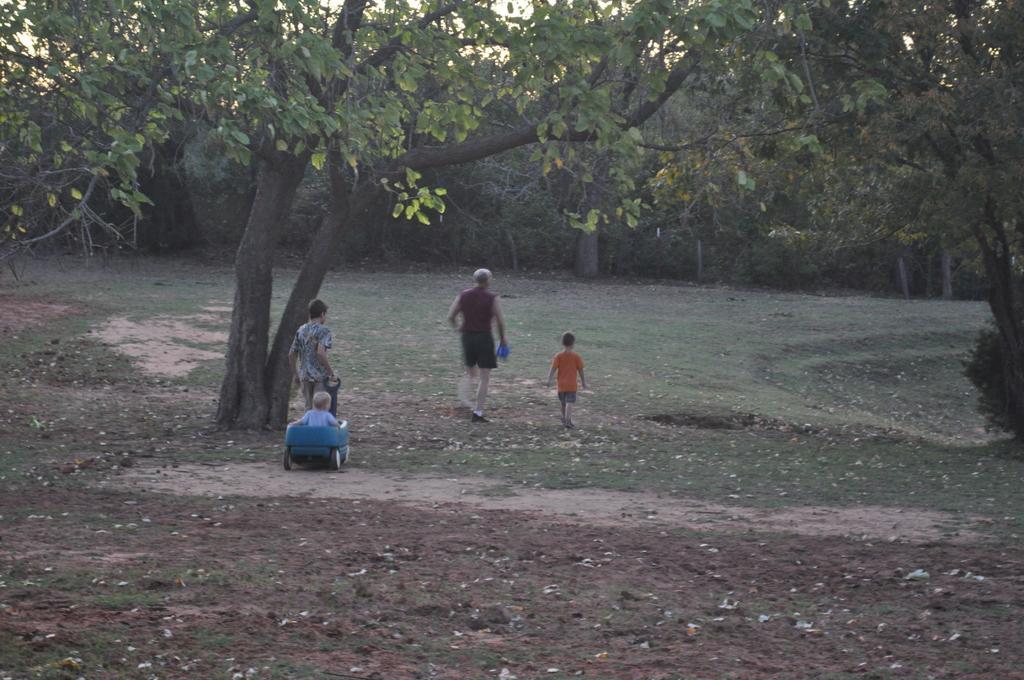How would you summarize this image in a sentence or two? In this picture there are some small kids playing in the playground. In the middle there is a huge tree and many trees in the background. 